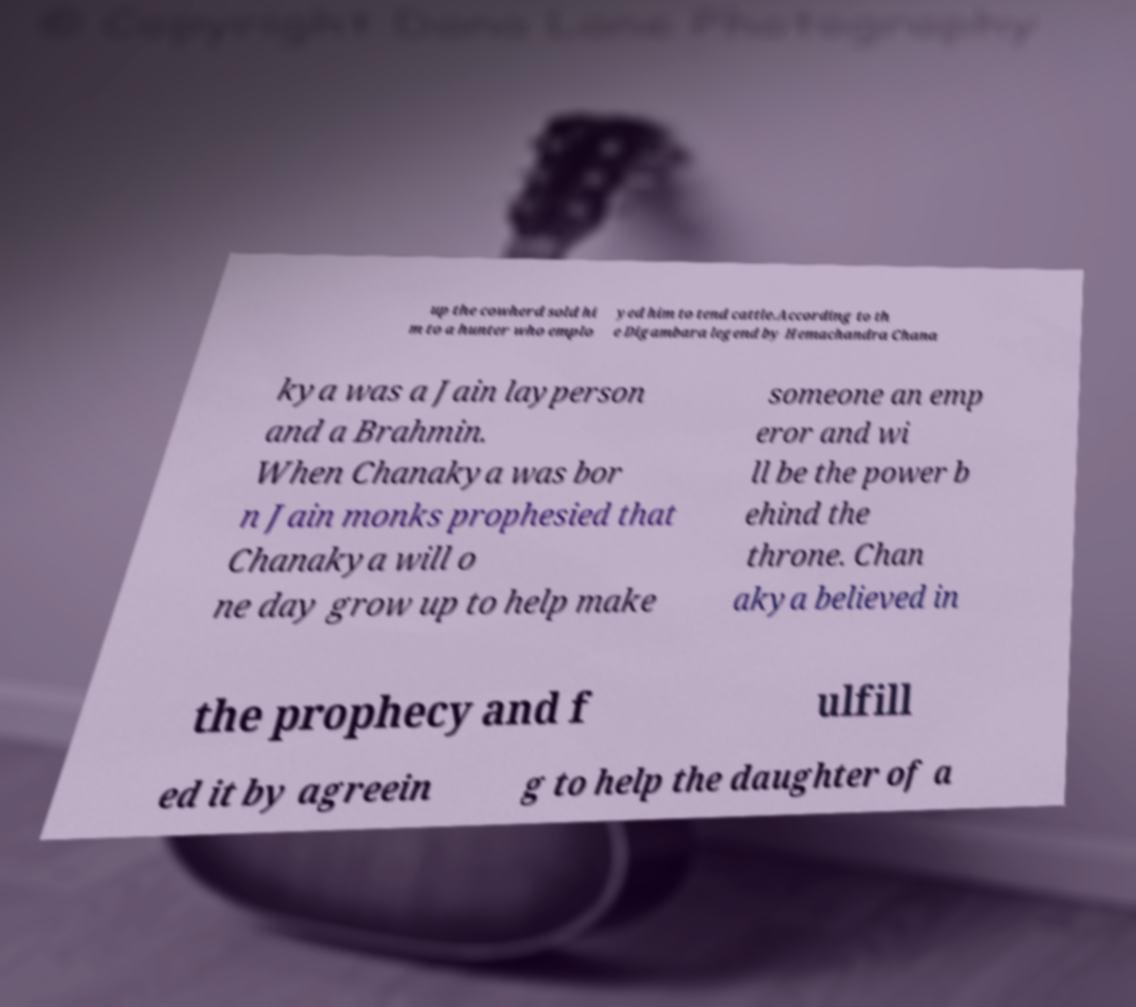Please read and relay the text visible in this image. What does it say? up the cowherd sold hi m to a hunter who emplo yed him to tend cattle.According to th e Digambara legend by Hemachandra Chana kya was a Jain layperson and a Brahmin. When Chanakya was bor n Jain monks prophesied that Chanakya will o ne day grow up to help make someone an emp eror and wi ll be the power b ehind the throne. Chan akya believed in the prophecy and f ulfill ed it by agreein g to help the daughter of a 